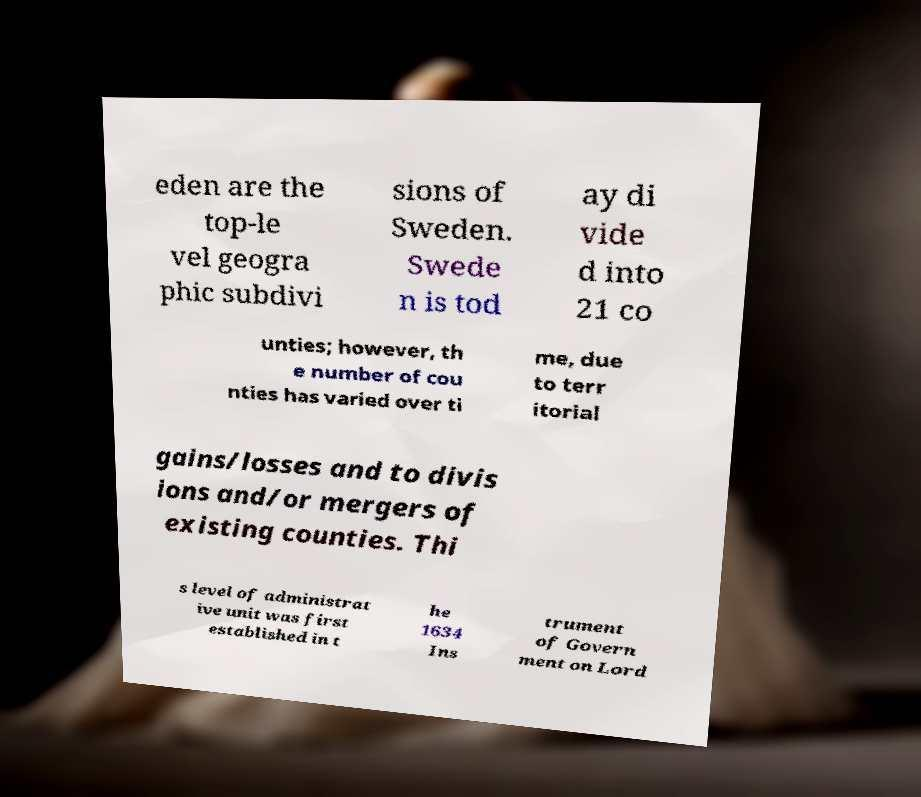I need the written content from this picture converted into text. Can you do that? eden are the top-le vel geogra phic subdivi sions of Sweden. Swede n is tod ay di vide d into 21 co unties; however, th e number of cou nties has varied over ti me, due to terr itorial gains/losses and to divis ions and/or mergers of existing counties. Thi s level of administrat ive unit was first established in t he 1634 Ins trument of Govern ment on Lord 